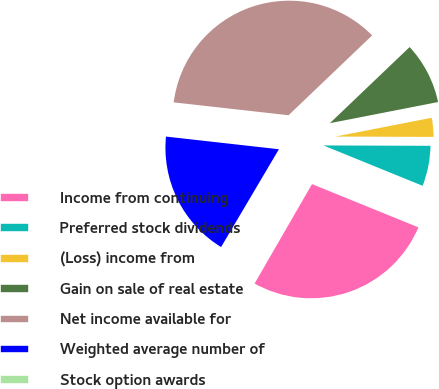Convert chart. <chart><loc_0><loc_0><loc_500><loc_500><pie_chart><fcel>Income from continuing<fcel>Preferred stock dividends<fcel>(Loss) income from<fcel>Gain on sale of real estate<fcel>Net income available for<fcel>Weighted average number of<fcel>Stock option awards<nl><fcel>27.19%<fcel>6.09%<fcel>3.13%<fcel>9.06%<fcel>36.09%<fcel>18.28%<fcel>0.16%<nl></chart> 